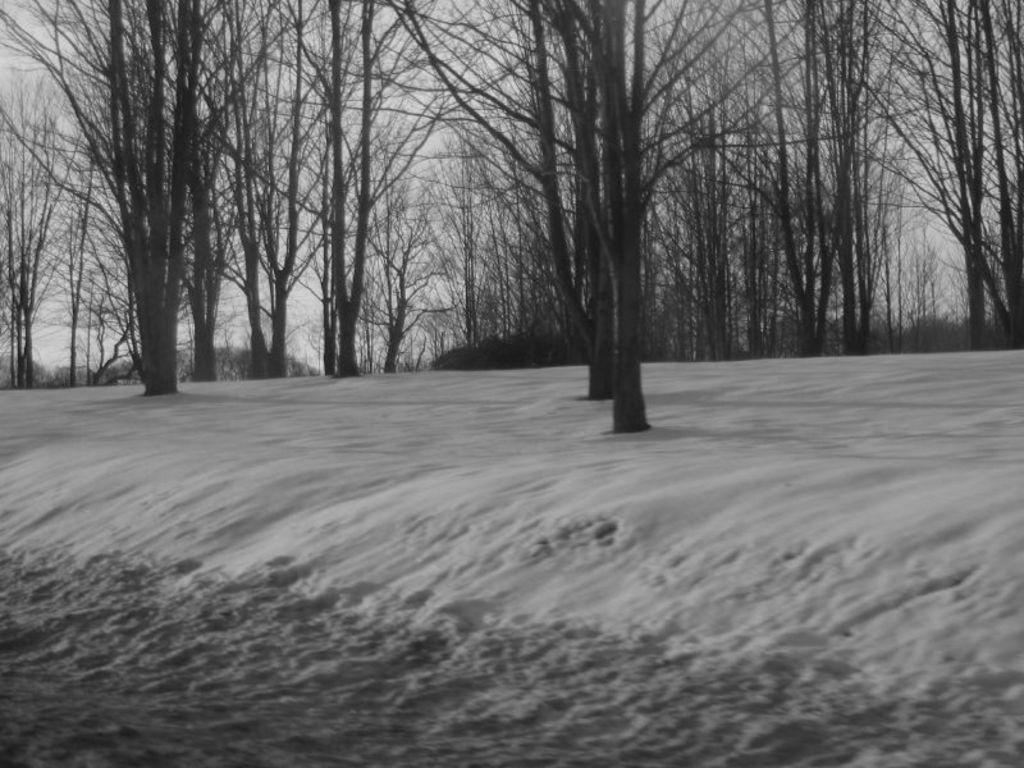What is the color scheme of the image? The image is black and white. What type of weather condition is depicted in the image? There is snow in the image. What type of natural vegetation can be seen in the image? There are trees in the image. How many geese are flying over the trees in the image? There are no geese present in the image; it only features snow and trees. What type of tin object can be seen in the image? There is no tin object present in the image. 